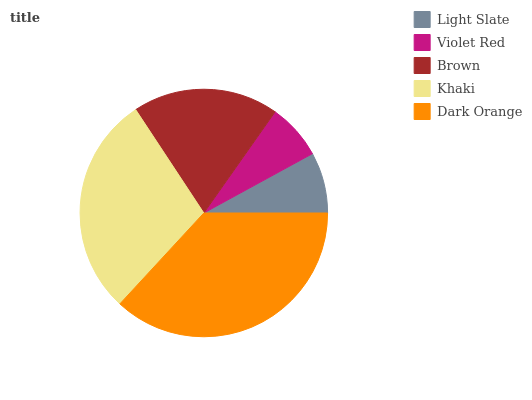Is Violet Red the minimum?
Answer yes or no. Yes. Is Dark Orange the maximum?
Answer yes or no. Yes. Is Brown the minimum?
Answer yes or no. No. Is Brown the maximum?
Answer yes or no. No. Is Brown greater than Violet Red?
Answer yes or no. Yes. Is Violet Red less than Brown?
Answer yes or no. Yes. Is Violet Red greater than Brown?
Answer yes or no. No. Is Brown less than Violet Red?
Answer yes or no. No. Is Brown the high median?
Answer yes or no. Yes. Is Brown the low median?
Answer yes or no. Yes. Is Light Slate the high median?
Answer yes or no. No. Is Khaki the low median?
Answer yes or no. No. 